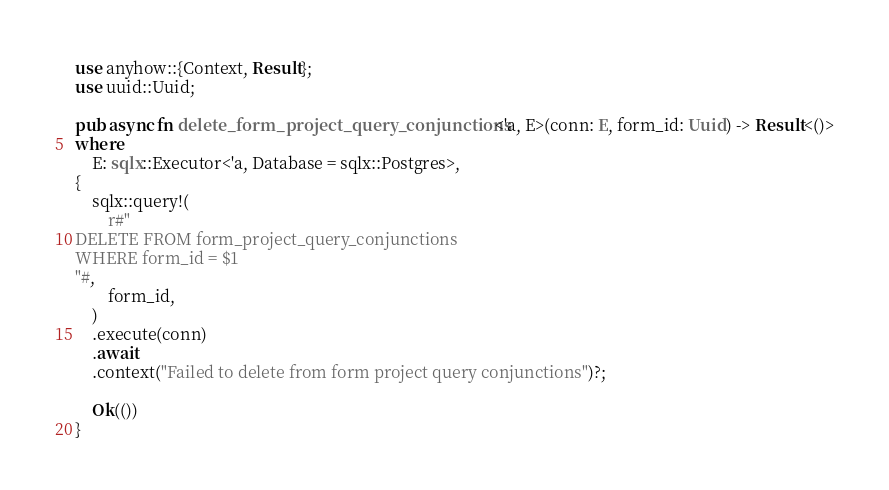Convert code to text. <code><loc_0><loc_0><loc_500><loc_500><_Rust_>use anyhow::{Context, Result};
use uuid::Uuid;

pub async fn delete_form_project_query_conjunctions<'a, E>(conn: E, form_id: Uuid) -> Result<()>
where
    E: sqlx::Executor<'a, Database = sqlx::Postgres>,
{
    sqlx::query!(
        r#"
DELETE FROM form_project_query_conjunctions
WHERE form_id = $1
"#,
        form_id,
    )
    .execute(conn)
    .await
    .context("Failed to delete from form project query conjunctions")?;

    Ok(())
}
</code> 